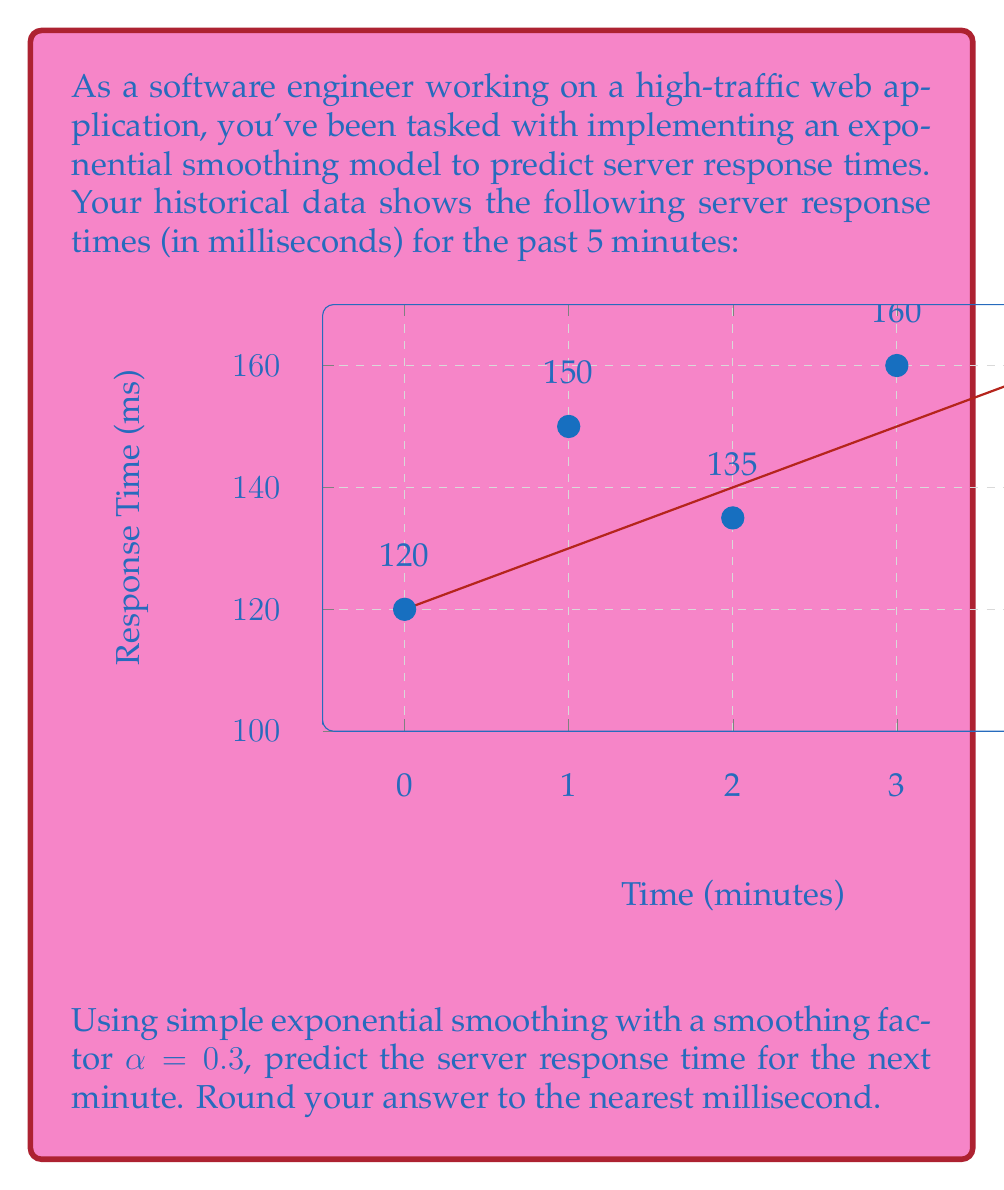Help me with this question. Let's apply simple exponential smoothing to predict the server response time:

1) The formula for simple exponential smoothing is:
   $$ F_{t+1} = \alpha Y_t + (1-\alpha)F_t $$
   where $F_{t+1}$ is the forecast for the next period, $Y_t$ is the actual value at time $t$, and $F_t$ is the previous forecast.

2) We're given $\alpha = 0.3$ and the last 5 observations: 120, 150, 135, 160, 145 ms.

3) We need to initialize $F_1$. A common method is to use the first observation:
   $F_1 = 120$ ms

4) Now we can calculate the subsequent forecasts:
   $F_2 = 0.3(150) + 0.7(120) = 129$ ms
   $F_3 = 0.3(135) + 0.7(129) = 130.8$ ms
   $F_4 = 0.3(160) + 0.7(130.8) = 139.56$ ms
   $F_5 = 0.3(145) + 0.7(139.56) = 141.192$ ms

5) The forecast for the next minute (t=6) is:
   $F_6 = 0.3(145) + 0.7(141.192) = 142.3344$ ms

6) Rounding to the nearest millisecond: 142 ms
Answer: 142 ms 